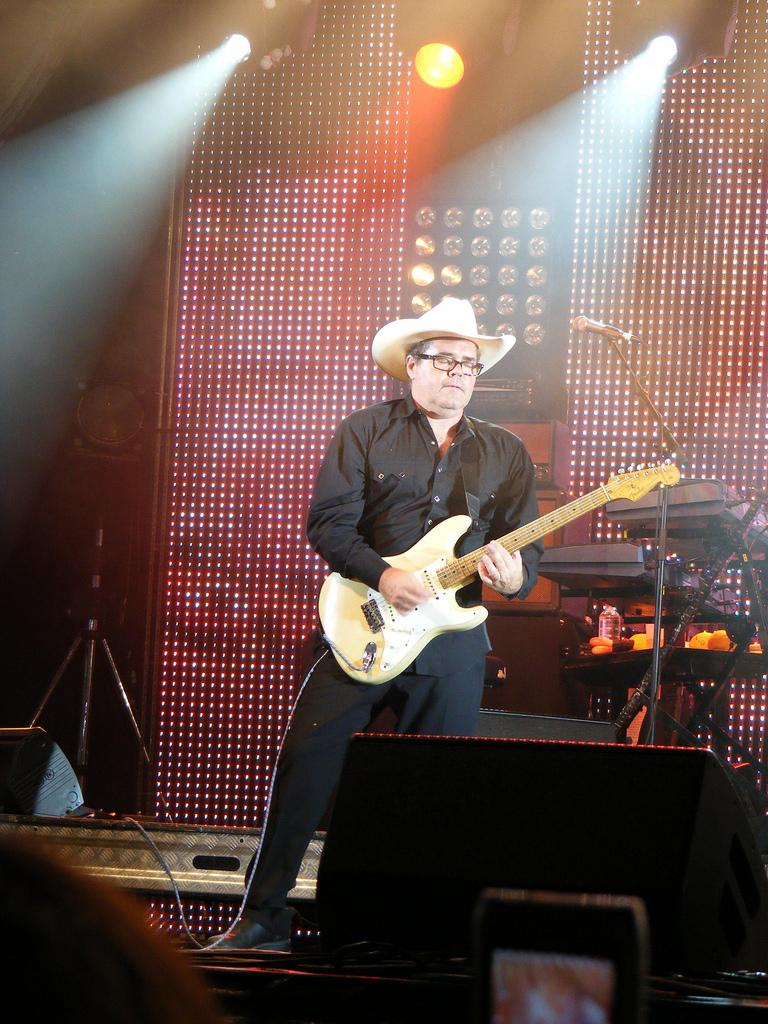What is the main subject of the image? The main subject of the image is a man. What is the man doing in the image? The man is standing in the image. What object is the man holding in the image? The man is holding a guitar in the image. What accessories is the man wearing in the image? The man is wearing a cap and a pair of glasses (specs) in the image. What other object can be seen in the image? There is a microphone (mic) in the image. What can be seen in the background of the image? There are lights visible in the background of the image. What type of desk is the man using to cover his trouble in the image? There is no desk present in the image, nor is there any indication of trouble. 